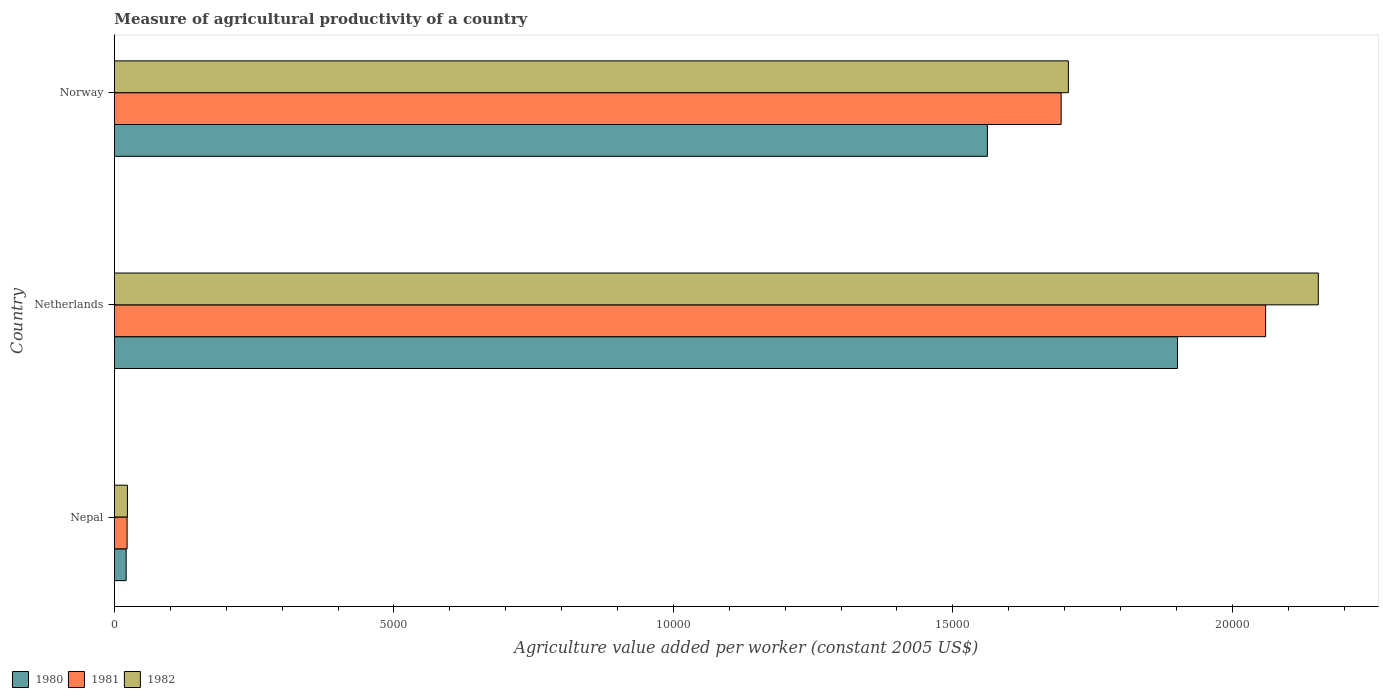How many groups of bars are there?
Keep it short and to the point. 3. Are the number of bars per tick equal to the number of legend labels?
Offer a terse response. Yes. How many bars are there on the 1st tick from the top?
Your answer should be compact. 3. In how many cases, is the number of bars for a given country not equal to the number of legend labels?
Provide a succinct answer. 0. What is the measure of agricultural productivity in 1982 in Norway?
Make the answer very short. 1.71e+04. Across all countries, what is the maximum measure of agricultural productivity in 1981?
Give a very brief answer. 2.06e+04. Across all countries, what is the minimum measure of agricultural productivity in 1981?
Your answer should be compact. 227.07. In which country was the measure of agricultural productivity in 1980 minimum?
Your answer should be compact. Nepal. What is the total measure of agricultural productivity in 1980 in the graph?
Your response must be concise. 3.48e+04. What is the difference between the measure of agricultural productivity in 1980 in Nepal and that in Norway?
Your answer should be compact. -1.54e+04. What is the difference between the measure of agricultural productivity in 1980 in Netherlands and the measure of agricultural productivity in 1981 in Nepal?
Provide a succinct answer. 1.88e+04. What is the average measure of agricultural productivity in 1980 per country?
Make the answer very short. 1.16e+04. What is the difference between the measure of agricultural productivity in 1981 and measure of agricultural productivity in 1980 in Netherlands?
Your response must be concise. 1576.8. What is the ratio of the measure of agricultural productivity in 1980 in Nepal to that in Norway?
Keep it short and to the point. 0.01. Is the measure of agricultural productivity in 1980 in Nepal less than that in Netherlands?
Ensure brevity in your answer.  Yes. What is the difference between the highest and the second highest measure of agricultural productivity in 1982?
Keep it short and to the point. 4471.16. What is the difference between the highest and the lowest measure of agricultural productivity in 1980?
Your response must be concise. 1.88e+04. What does the 1st bar from the bottom in Nepal represents?
Provide a short and direct response. 1980. Is it the case that in every country, the sum of the measure of agricultural productivity in 1980 and measure of agricultural productivity in 1982 is greater than the measure of agricultural productivity in 1981?
Make the answer very short. Yes. How many bars are there?
Your answer should be compact. 9. Are all the bars in the graph horizontal?
Your answer should be compact. Yes. What is the difference between two consecutive major ticks on the X-axis?
Your answer should be very brief. 5000. Does the graph contain grids?
Ensure brevity in your answer.  No. Where does the legend appear in the graph?
Give a very brief answer. Bottom left. What is the title of the graph?
Provide a short and direct response. Measure of agricultural productivity of a country. What is the label or title of the X-axis?
Provide a succinct answer. Agriculture value added per worker (constant 2005 US$). What is the Agriculture value added per worker (constant 2005 US$) in 1980 in Nepal?
Make the answer very short. 210.09. What is the Agriculture value added per worker (constant 2005 US$) in 1981 in Nepal?
Provide a short and direct response. 227.07. What is the Agriculture value added per worker (constant 2005 US$) of 1982 in Nepal?
Provide a succinct answer. 232.83. What is the Agriculture value added per worker (constant 2005 US$) of 1980 in Netherlands?
Give a very brief answer. 1.90e+04. What is the Agriculture value added per worker (constant 2005 US$) of 1981 in Netherlands?
Your answer should be very brief. 2.06e+04. What is the Agriculture value added per worker (constant 2005 US$) in 1982 in Netherlands?
Make the answer very short. 2.15e+04. What is the Agriculture value added per worker (constant 2005 US$) in 1980 in Norway?
Your response must be concise. 1.56e+04. What is the Agriculture value added per worker (constant 2005 US$) of 1981 in Norway?
Your answer should be compact. 1.69e+04. What is the Agriculture value added per worker (constant 2005 US$) in 1982 in Norway?
Make the answer very short. 1.71e+04. Across all countries, what is the maximum Agriculture value added per worker (constant 2005 US$) in 1980?
Provide a succinct answer. 1.90e+04. Across all countries, what is the maximum Agriculture value added per worker (constant 2005 US$) of 1981?
Ensure brevity in your answer.  2.06e+04. Across all countries, what is the maximum Agriculture value added per worker (constant 2005 US$) in 1982?
Provide a succinct answer. 2.15e+04. Across all countries, what is the minimum Agriculture value added per worker (constant 2005 US$) in 1980?
Make the answer very short. 210.09. Across all countries, what is the minimum Agriculture value added per worker (constant 2005 US$) of 1981?
Ensure brevity in your answer.  227.07. Across all countries, what is the minimum Agriculture value added per worker (constant 2005 US$) in 1982?
Give a very brief answer. 232.83. What is the total Agriculture value added per worker (constant 2005 US$) of 1980 in the graph?
Give a very brief answer. 3.48e+04. What is the total Agriculture value added per worker (constant 2005 US$) of 1981 in the graph?
Offer a very short reply. 3.78e+04. What is the total Agriculture value added per worker (constant 2005 US$) of 1982 in the graph?
Your answer should be very brief. 3.88e+04. What is the difference between the Agriculture value added per worker (constant 2005 US$) in 1980 in Nepal and that in Netherlands?
Give a very brief answer. -1.88e+04. What is the difference between the Agriculture value added per worker (constant 2005 US$) of 1981 in Nepal and that in Netherlands?
Offer a terse response. -2.04e+04. What is the difference between the Agriculture value added per worker (constant 2005 US$) in 1982 in Nepal and that in Netherlands?
Make the answer very short. -2.13e+04. What is the difference between the Agriculture value added per worker (constant 2005 US$) in 1980 in Nepal and that in Norway?
Your answer should be compact. -1.54e+04. What is the difference between the Agriculture value added per worker (constant 2005 US$) of 1981 in Nepal and that in Norway?
Give a very brief answer. -1.67e+04. What is the difference between the Agriculture value added per worker (constant 2005 US$) of 1982 in Nepal and that in Norway?
Offer a terse response. -1.68e+04. What is the difference between the Agriculture value added per worker (constant 2005 US$) in 1980 in Netherlands and that in Norway?
Give a very brief answer. 3401.71. What is the difference between the Agriculture value added per worker (constant 2005 US$) of 1981 in Netherlands and that in Norway?
Offer a very short reply. 3658.56. What is the difference between the Agriculture value added per worker (constant 2005 US$) in 1982 in Netherlands and that in Norway?
Your answer should be compact. 4471.16. What is the difference between the Agriculture value added per worker (constant 2005 US$) of 1980 in Nepal and the Agriculture value added per worker (constant 2005 US$) of 1981 in Netherlands?
Ensure brevity in your answer.  -2.04e+04. What is the difference between the Agriculture value added per worker (constant 2005 US$) in 1980 in Nepal and the Agriculture value added per worker (constant 2005 US$) in 1982 in Netherlands?
Offer a terse response. -2.13e+04. What is the difference between the Agriculture value added per worker (constant 2005 US$) of 1981 in Nepal and the Agriculture value added per worker (constant 2005 US$) of 1982 in Netherlands?
Ensure brevity in your answer.  -2.13e+04. What is the difference between the Agriculture value added per worker (constant 2005 US$) of 1980 in Nepal and the Agriculture value added per worker (constant 2005 US$) of 1981 in Norway?
Provide a short and direct response. -1.67e+04. What is the difference between the Agriculture value added per worker (constant 2005 US$) of 1980 in Nepal and the Agriculture value added per worker (constant 2005 US$) of 1982 in Norway?
Your response must be concise. -1.69e+04. What is the difference between the Agriculture value added per worker (constant 2005 US$) in 1981 in Nepal and the Agriculture value added per worker (constant 2005 US$) in 1982 in Norway?
Offer a terse response. -1.68e+04. What is the difference between the Agriculture value added per worker (constant 2005 US$) of 1980 in Netherlands and the Agriculture value added per worker (constant 2005 US$) of 1981 in Norway?
Your response must be concise. 2081.76. What is the difference between the Agriculture value added per worker (constant 2005 US$) of 1980 in Netherlands and the Agriculture value added per worker (constant 2005 US$) of 1982 in Norway?
Make the answer very short. 1952.22. What is the difference between the Agriculture value added per worker (constant 2005 US$) in 1981 in Netherlands and the Agriculture value added per worker (constant 2005 US$) in 1982 in Norway?
Provide a short and direct response. 3529.02. What is the average Agriculture value added per worker (constant 2005 US$) of 1980 per country?
Your answer should be very brief. 1.16e+04. What is the average Agriculture value added per worker (constant 2005 US$) of 1981 per country?
Your answer should be very brief. 1.26e+04. What is the average Agriculture value added per worker (constant 2005 US$) in 1982 per country?
Give a very brief answer. 1.29e+04. What is the difference between the Agriculture value added per worker (constant 2005 US$) of 1980 and Agriculture value added per worker (constant 2005 US$) of 1981 in Nepal?
Offer a very short reply. -16.98. What is the difference between the Agriculture value added per worker (constant 2005 US$) in 1980 and Agriculture value added per worker (constant 2005 US$) in 1982 in Nepal?
Provide a succinct answer. -22.74. What is the difference between the Agriculture value added per worker (constant 2005 US$) of 1981 and Agriculture value added per worker (constant 2005 US$) of 1982 in Nepal?
Provide a short and direct response. -5.76. What is the difference between the Agriculture value added per worker (constant 2005 US$) of 1980 and Agriculture value added per worker (constant 2005 US$) of 1981 in Netherlands?
Offer a very short reply. -1576.8. What is the difference between the Agriculture value added per worker (constant 2005 US$) in 1980 and Agriculture value added per worker (constant 2005 US$) in 1982 in Netherlands?
Ensure brevity in your answer.  -2518.94. What is the difference between the Agriculture value added per worker (constant 2005 US$) of 1981 and Agriculture value added per worker (constant 2005 US$) of 1982 in Netherlands?
Offer a very short reply. -942.14. What is the difference between the Agriculture value added per worker (constant 2005 US$) in 1980 and Agriculture value added per worker (constant 2005 US$) in 1981 in Norway?
Your response must be concise. -1319.95. What is the difference between the Agriculture value added per worker (constant 2005 US$) in 1980 and Agriculture value added per worker (constant 2005 US$) in 1982 in Norway?
Your answer should be compact. -1449.49. What is the difference between the Agriculture value added per worker (constant 2005 US$) in 1981 and Agriculture value added per worker (constant 2005 US$) in 1982 in Norway?
Your response must be concise. -129.54. What is the ratio of the Agriculture value added per worker (constant 2005 US$) of 1980 in Nepal to that in Netherlands?
Keep it short and to the point. 0.01. What is the ratio of the Agriculture value added per worker (constant 2005 US$) of 1981 in Nepal to that in Netherlands?
Give a very brief answer. 0.01. What is the ratio of the Agriculture value added per worker (constant 2005 US$) in 1982 in Nepal to that in Netherlands?
Ensure brevity in your answer.  0.01. What is the ratio of the Agriculture value added per worker (constant 2005 US$) in 1980 in Nepal to that in Norway?
Provide a succinct answer. 0.01. What is the ratio of the Agriculture value added per worker (constant 2005 US$) of 1981 in Nepal to that in Norway?
Provide a succinct answer. 0.01. What is the ratio of the Agriculture value added per worker (constant 2005 US$) of 1982 in Nepal to that in Norway?
Your answer should be very brief. 0.01. What is the ratio of the Agriculture value added per worker (constant 2005 US$) of 1980 in Netherlands to that in Norway?
Your answer should be compact. 1.22. What is the ratio of the Agriculture value added per worker (constant 2005 US$) of 1981 in Netherlands to that in Norway?
Make the answer very short. 1.22. What is the ratio of the Agriculture value added per worker (constant 2005 US$) of 1982 in Netherlands to that in Norway?
Provide a short and direct response. 1.26. What is the difference between the highest and the second highest Agriculture value added per worker (constant 2005 US$) of 1980?
Provide a short and direct response. 3401.71. What is the difference between the highest and the second highest Agriculture value added per worker (constant 2005 US$) in 1981?
Make the answer very short. 3658.56. What is the difference between the highest and the second highest Agriculture value added per worker (constant 2005 US$) of 1982?
Offer a very short reply. 4471.16. What is the difference between the highest and the lowest Agriculture value added per worker (constant 2005 US$) of 1980?
Provide a short and direct response. 1.88e+04. What is the difference between the highest and the lowest Agriculture value added per worker (constant 2005 US$) of 1981?
Provide a succinct answer. 2.04e+04. What is the difference between the highest and the lowest Agriculture value added per worker (constant 2005 US$) of 1982?
Keep it short and to the point. 2.13e+04. 